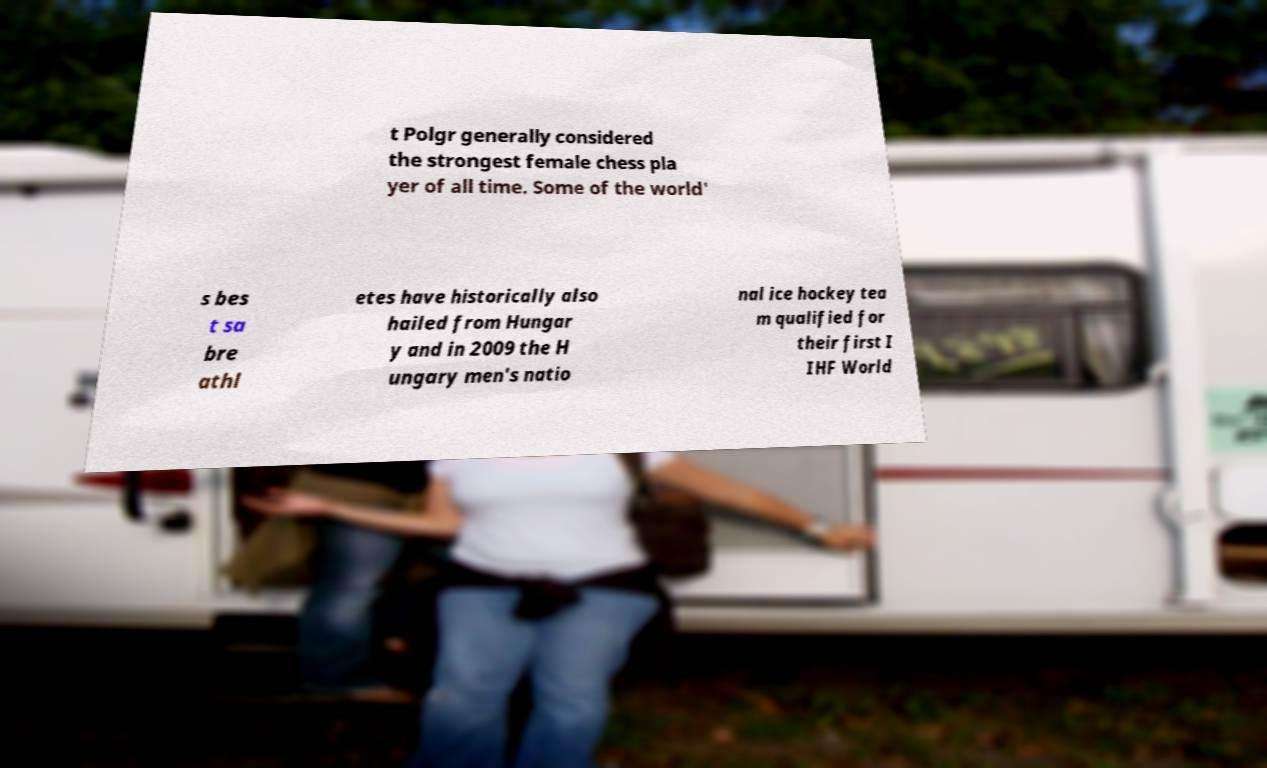Could you extract and type out the text from this image? t Polgr generally considered the strongest female chess pla yer of all time. Some of the world' s bes t sa bre athl etes have historically also hailed from Hungar y and in 2009 the H ungary men's natio nal ice hockey tea m qualified for their first I IHF World 